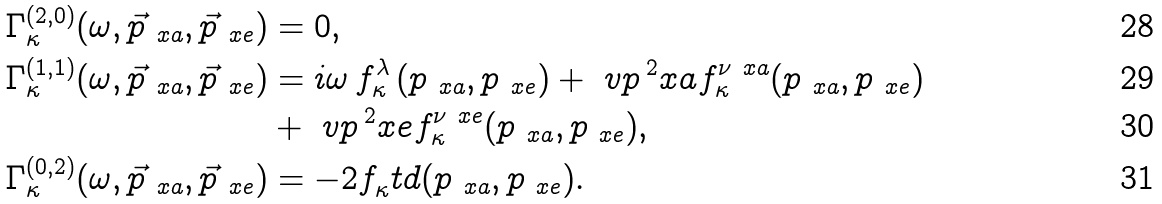<formula> <loc_0><loc_0><loc_500><loc_500>\Gamma _ { \kappa } ^ { ( 2 , 0 ) } ( \omega , \vec { p } _ { \ x a } , \vec { p } _ { \ x e } ) & = 0 , \\ \Gamma _ { \kappa } ^ { ( 1 , 1 ) } ( \omega , \vec { p } _ { \ x a } , \vec { p } _ { \ x e } ) & = i \omega \, f _ { \kappa } ^ { \lambda } \left ( p _ { \ x a } , p _ { \ x e } \right ) + \ v p \, ^ { 2 } _ { \ } x a f _ { \kappa } ^ { \nu \ x a } ( p _ { \ x a } , p _ { \ x e } ) \\ & + \ v p \, ^ { 2 } _ { \ } x e f _ { \kappa } ^ { \nu \ x e } ( p _ { \ x a } , p _ { \ x e } ) , \\ \Gamma _ { \kappa } ^ { ( 0 , 2 ) } ( \omega , \vec { p } _ { \ x a } , \vec { p } _ { \ x e } ) & = - 2 f _ { \kappa } ^ { \ } t d ( p _ { \ x a } , p _ { \ x e } ) .</formula> 